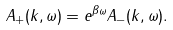<formula> <loc_0><loc_0><loc_500><loc_500>A _ { + } ( { k } , \omega ) = e ^ { \beta \omega } A _ { - } ( { k } , \omega ) .</formula> 